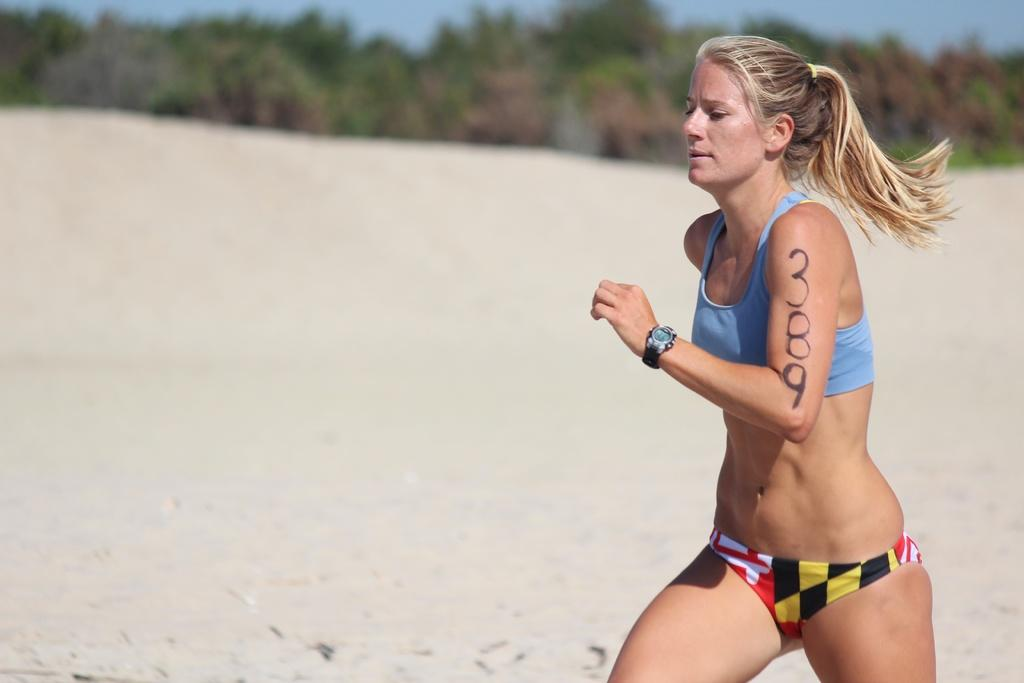Where was the picture taken? The picture was clicked outside. What is the woman in the picture doing? The woman is running on the ground. What can be seen in the background of the picture? The sky, trees, and other unspecified objects are visible in the background. What type of scent can be smelled coming from the woman in the image? There is no information about any scent in the image, and it is not possible to smell anything through a picture. 